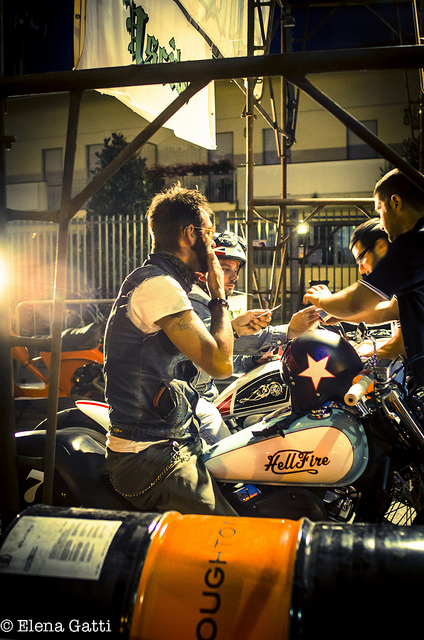Identify and read out the text in this image. C Elena Gatti 7 